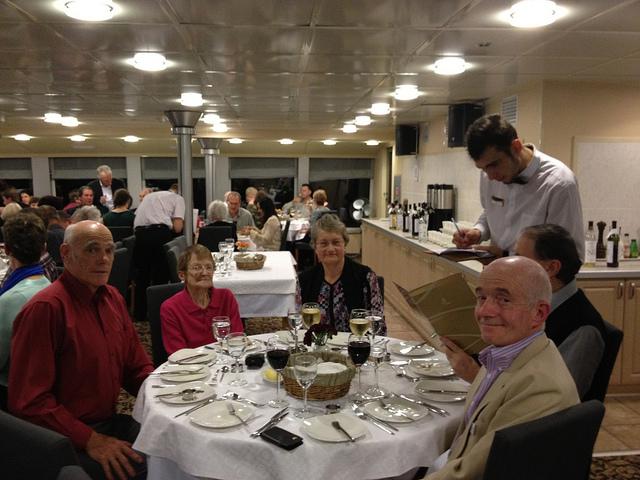Is there food on the plates in the picture?
Be succinct. No. Are these people going to prom?
Keep it brief. No. Are these inmates taking over the asylum?
Answer briefly. No. Are there any candles on the tables?
Keep it brief. No. Have these people been served food yet?
Keep it brief. No. 